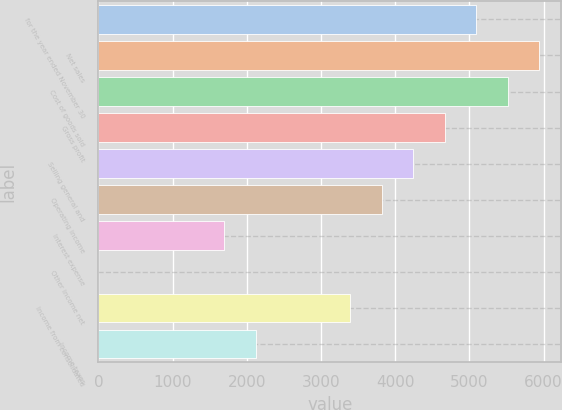Convert chart. <chart><loc_0><loc_0><loc_500><loc_500><bar_chart><fcel>for the year ended November 30<fcel>Net sales<fcel>Cost of goods sold<fcel>Gross profit<fcel>Selling general and<fcel>Operating income<fcel>Interest expense<fcel>Other income net<fcel>Income from consolidated<fcel>Income taxes<nl><fcel>5091.62<fcel>5940.04<fcel>5515.83<fcel>4667.41<fcel>4243.2<fcel>3818.99<fcel>1697.94<fcel>1.1<fcel>3394.78<fcel>2122.15<nl></chart> 